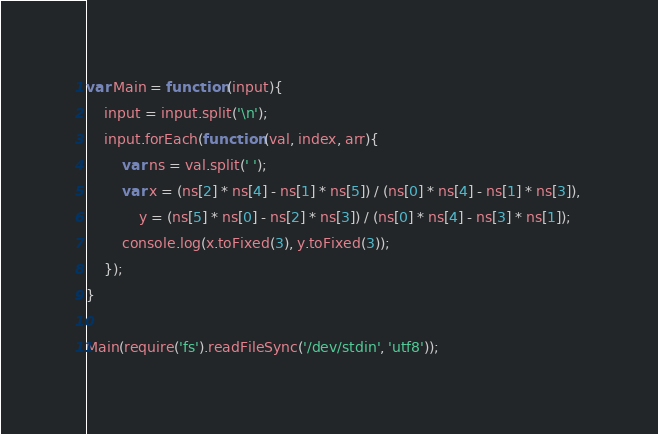<code> <loc_0><loc_0><loc_500><loc_500><_JavaScript_>var Main = function (input){
    input = input.split('\n');
    input.forEach(function (val, index, arr){
        var ns = val.split(' ');
        var x = (ns[2] * ns[4] - ns[1] * ns[5]) / (ns[0] * ns[4] - ns[1] * ns[3]), 
            y = (ns[5] * ns[0] - ns[2] * ns[3]) / (ns[0] * ns[4] - ns[3] * ns[1]);
        console.log(x.toFixed(3), y.toFixed(3));
    });
}

Main(require('fs').readFileSync('/dev/stdin', 'utf8'));</code> 